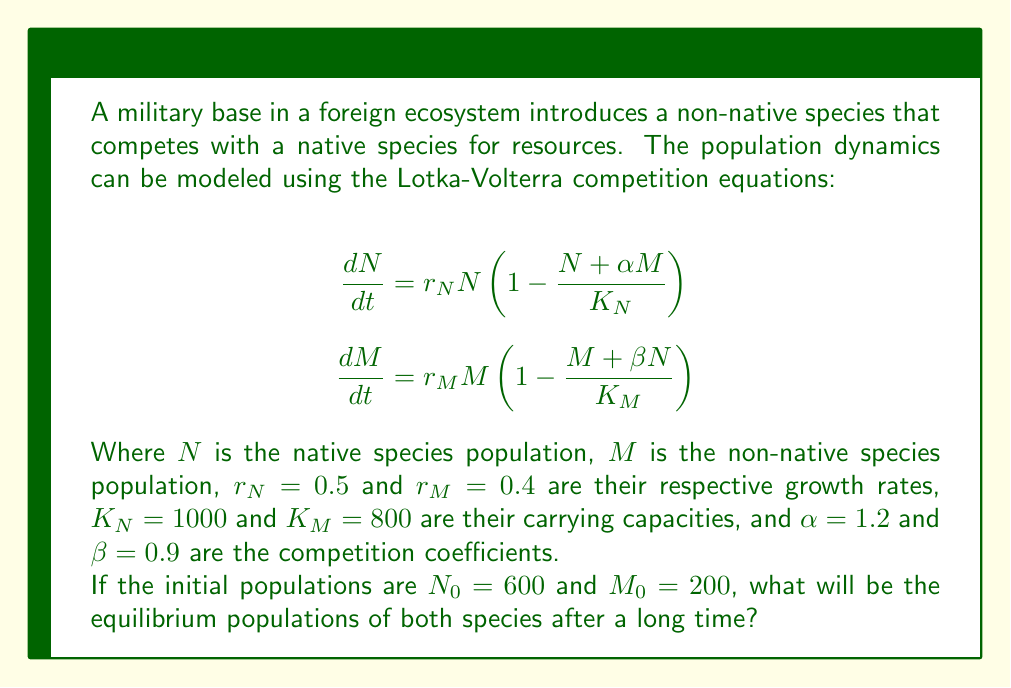Could you help me with this problem? To solve this problem, we need to find the equilibrium points of the system. At equilibrium, the rate of change for both populations will be zero:

$$\frac{dN}{dt} = 0 \text{ and } \frac{dM}{dt} = 0$$

Let's solve these equations:

1) From $\frac{dN}{dt} = 0$:
   $$0 = r_N N \left(1 - \frac{N + \alpha M}{K_N}\right)$$
   This is true when $N = 0$ or when $1 - \frac{N + \alpha M}{K_N} = 0$
   From the second condition: $N + \alpha M = K_N$
   $$N = K_N - \alpha M = 1000 - 1.2M \quad (1)$$

2) From $\frac{dM}{dt} = 0$:
   $$0 = r_M M \left(1 - \frac{M + \beta N}{K_M}\right)$$
   This is true when $M = 0$ or when $1 - \frac{M + \beta N}{K_M} = 0$
   From the second condition: $M + \beta N = K_M$
   $$M = K_M - \beta N = 800 - 0.9N \quad (2)$$

3) Substitute (2) into (1):
   $$N = 1000 - 1.2(800 - 0.9N)$$
   $$N = 1000 - 960 + 1.08N$$
   $$-0.08N = -40$$
   $$N = 500$$

4) Substitute this value of $N$ back into (2):
   $$M = 800 - 0.9(500) = 350$$

Therefore, the equilibrium point is $(N, M) = (500, 350)$.

To verify if this is a stable equilibrium, we would need to perform a stability analysis, which is beyond the scope of this question. However, given the initial conditions and the nature of the competition model, this equilibrium is likely to be stable and attractive.
Answer: The equilibrium populations after a long time will be approximately 500 for the native species $(N)$ and 350 for the non-native species $(M)$. 